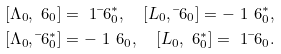<formula> <loc_0><loc_0><loc_500><loc_500>& [ \Lambda _ { 0 } , \ 6 _ { 0 } ] = \ 1 \bar { \ } 6 _ { 0 } ^ { * } , \quad [ L _ { 0 } , \bar { \ } 6 _ { 0 } ] = - \ 1 \ 6 _ { 0 } ^ { * } , \\ & [ \Lambda _ { 0 } , \bar { \ } 6 _ { 0 } ^ { * } ] = - \ 1 \ 6 _ { 0 } , \quad [ L _ { 0 } , \ 6 _ { 0 } ^ { * } ] = \ 1 \bar { \ } 6 _ { 0 } .</formula> 